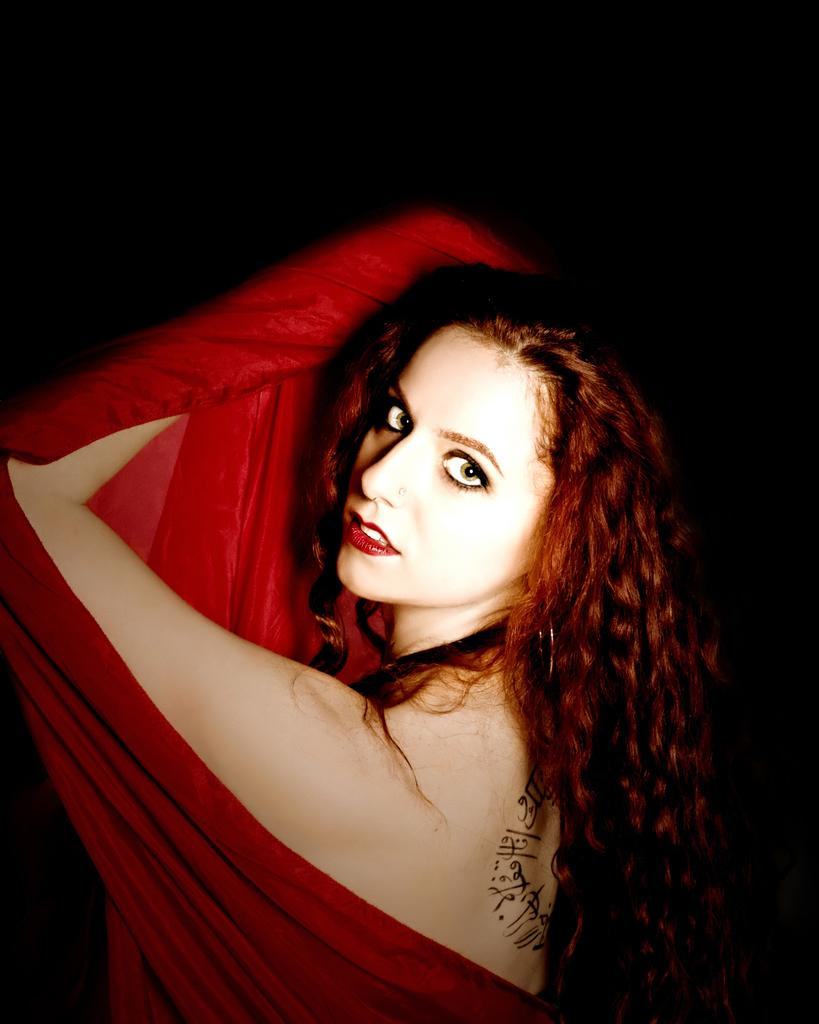Who is the main subject in the image? There is a woman in the image. What is the woman wearing? The woman is wearing clothes. Can you describe any accessories or jewelry the woman is wearing? The woman has a nose stud. What is the color or tone of the background in the image? The background of the image is dark. What type of print can be seen on the woman's shirt in the image? There is no print visible on the woman's shirt in the image. What color is the pencil the woman is holding in the image? There is no pencil present in the image. 